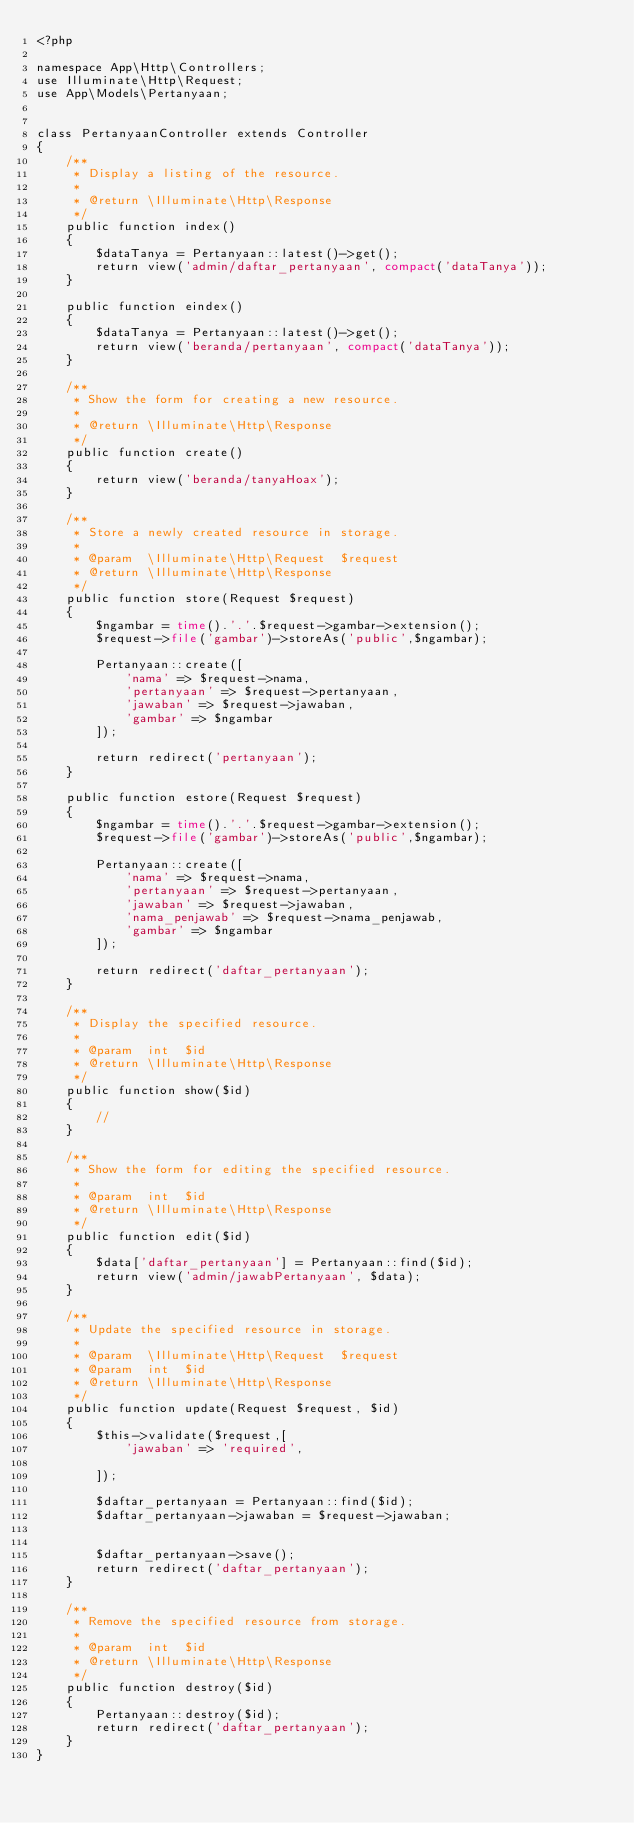<code> <loc_0><loc_0><loc_500><loc_500><_PHP_><?php

namespace App\Http\Controllers;
use Illuminate\Http\Request;
use App\Models\Pertanyaan;


class PertanyaanController extends Controller
{
    /**
     * Display a listing of the resource.
     *
     * @return \Illuminate\Http\Response
     */
    public function index()
    {
        $dataTanya = Pertanyaan::latest()->get();
        return view('admin/daftar_pertanyaan', compact('dataTanya'));
    }

    public function eindex()
    {
        $dataTanya = Pertanyaan::latest()->get();
        return view('beranda/pertanyaan', compact('dataTanya'));
    }

    /**
     * Show the form for creating a new resource.
     *
     * @return \Illuminate\Http\Response
     */
    public function create()
    {
        return view('beranda/tanyaHoax');
    }

    /**
     * Store a newly created resource in storage.
     *
     * @param  \Illuminate\Http\Request  $request
     * @return \Illuminate\Http\Response
     */
    public function store(Request $request)
    {
        $ngambar = time().'.'.$request->gambar->extension();
        $request->file('gambar')->storeAs('public',$ngambar);

        Pertanyaan::create([
            'nama' => $request->nama,
            'pertanyaan' => $request->pertanyaan,
            'jawaban' => $request->jawaban,
            'gambar' => $ngambar 
        ]);

        return redirect('pertanyaan'); 
    }

    public function estore(Request $request)
    {
        $ngambar = time().'.'.$request->gambar->extension();
        $request->file('gambar')->storeAs('public',$ngambar);

        Pertanyaan::create([
            'nama' => $request->nama,
            'pertanyaan' => $request->pertanyaan,
            'jawaban' => $request->jawaban,
            'nama_penjawab' => $request->nama_penjawab,
            'gambar' => $ngambar 
        ]);

        return redirect('daftar_pertanyaan'); 
    }

    /**
     * Display the specified resource.
     *
     * @param  int  $id
     * @return \Illuminate\Http\Response
     */
    public function show($id)
    {
        //
    }

    /**
     * Show the form for editing the specified resource.
     *
     * @param  int  $id
     * @return \Illuminate\Http\Response
     */
    public function edit($id)
    {
        $data['daftar_pertanyaan'] = Pertanyaan::find($id);
        return view('admin/jawabPertanyaan', $data);
    }

    /**
     * Update the specified resource in storage.
     *
     * @param  \Illuminate\Http\Request  $request
     * @param  int  $id
     * @return \Illuminate\Http\Response
     */
    public function update(Request $request, $id)
    {
        $this->validate($request,[
            'jawaban' => 'required',
            
        ]);

        $daftar_pertanyaan = Pertanyaan::find($id);
        $daftar_pertanyaan->jawaban = $request->jawaban;
        

        $daftar_pertanyaan->save();
        return redirect('daftar_pertanyaan');
    }

    /**
     * Remove the specified resource from storage.
     *
     * @param  int  $id
     * @return \Illuminate\Http\Response
     */
    public function destroy($id)
    {
        Pertanyaan::destroy($id);
        return redirect('daftar_pertanyaan');
    }
}
</code> 